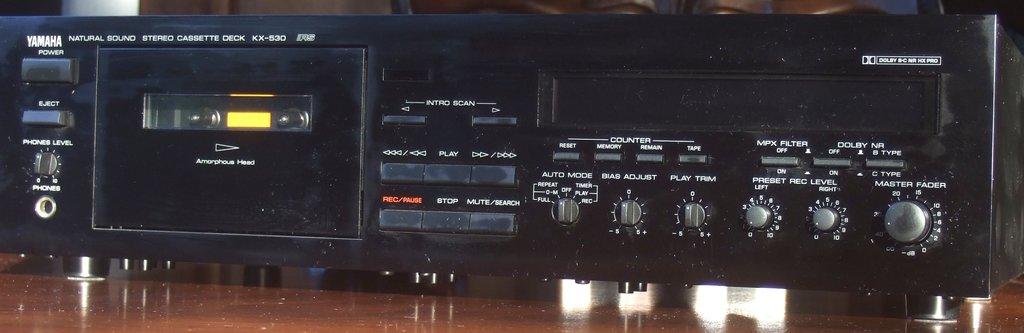What company built the cassette deck?
Ensure brevity in your answer.  Yamaha. What does the knob on the right hand side say?
Make the answer very short. Master fader. 